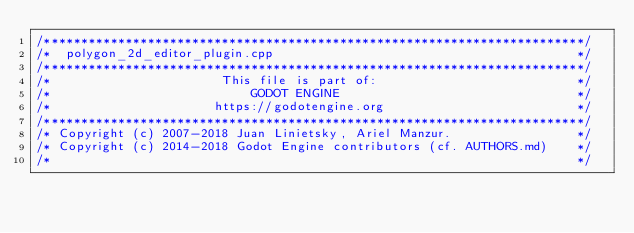<code> <loc_0><loc_0><loc_500><loc_500><_C++_>/*************************************************************************/
/*  polygon_2d_editor_plugin.cpp                                         */
/*************************************************************************/
/*                       This file is part of:                           */
/*                           GODOT ENGINE                                */
/*                      https://godotengine.org                          */
/*************************************************************************/
/* Copyright (c) 2007-2018 Juan Linietsky, Ariel Manzur.                 */
/* Copyright (c) 2014-2018 Godot Engine contributors (cf. AUTHORS.md)    */
/*                                                                       */</code> 